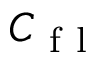<formula> <loc_0><loc_0><loc_500><loc_500>C _ { f l }</formula> 